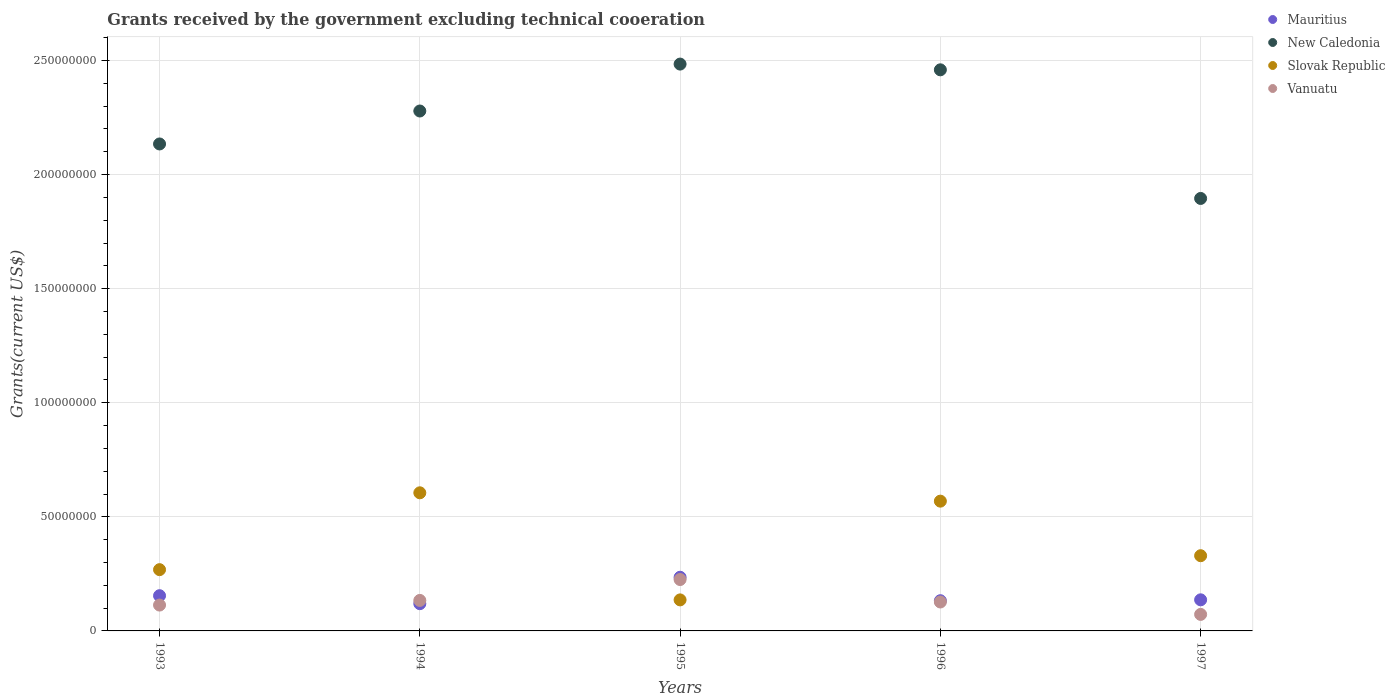Is the number of dotlines equal to the number of legend labels?
Make the answer very short. Yes. What is the total grants received by the government in Vanuatu in 1993?
Keep it short and to the point. 1.13e+07. Across all years, what is the maximum total grants received by the government in Slovak Republic?
Ensure brevity in your answer.  6.05e+07. Across all years, what is the minimum total grants received by the government in Slovak Republic?
Your answer should be very brief. 1.36e+07. In which year was the total grants received by the government in Mauritius maximum?
Your response must be concise. 1995. In which year was the total grants received by the government in New Caledonia minimum?
Your answer should be compact. 1997. What is the total total grants received by the government in Vanuatu in the graph?
Your response must be concise. 6.71e+07. What is the difference between the total grants received by the government in New Caledonia in 1993 and that in 1997?
Keep it short and to the point. 2.39e+07. What is the difference between the total grants received by the government in Mauritius in 1997 and the total grants received by the government in Slovak Republic in 1996?
Offer a terse response. -4.32e+07. What is the average total grants received by the government in Vanuatu per year?
Offer a terse response. 1.34e+07. In the year 1994, what is the difference between the total grants received by the government in Slovak Republic and total grants received by the government in Mauritius?
Keep it short and to the point. 4.86e+07. In how many years, is the total grants received by the government in Mauritius greater than 130000000 US$?
Keep it short and to the point. 0. What is the ratio of the total grants received by the government in Mauritius in 1994 to that in 1995?
Provide a short and direct response. 0.51. Is the difference between the total grants received by the government in Slovak Republic in 1994 and 1995 greater than the difference between the total grants received by the government in Mauritius in 1994 and 1995?
Your answer should be compact. Yes. What is the difference between the highest and the second highest total grants received by the government in New Caledonia?
Your answer should be compact. 2.51e+06. What is the difference between the highest and the lowest total grants received by the government in Vanuatu?
Offer a terse response. 1.53e+07. In how many years, is the total grants received by the government in New Caledonia greater than the average total grants received by the government in New Caledonia taken over all years?
Keep it short and to the point. 3. Does the total grants received by the government in Slovak Republic monotonically increase over the years?
Provide a short and direct response. No. Is the total grants received by the government in Vanuatu strictly greater than the total grants received by the government in Slovak Republic over the years?
Provide a succinct answer. No. Are the values on the major ticks of Y-axis written in scientific E-notation?
Make the answer very short. No. Does the graph contain any zero values?
Your answer should be compact. No. Does the graph contain grids?
Provide a short and direct response. Yes. How many legend labels are there?
Your answer should be compact. 4. What is the title of the graph?
Your answer should be compact. Grants received by the government excluding technical cooeration. What is the label or title of the Y-axis?
Provide a short and direct response. Grants(current US$). What is the Grants(current US$) of Mauritius in 1993?
Give a very brief answer. 1.54e+07. What is the Grants(current US$) of New Caledonia in 1993?
Provide a short and direct response. 2.13e+08. What is the Grants(current US$) in Slovak Republic in 1993?
Your answer should be compact. 2.68e+07. What is the Grants(current US$) in Vanuatu in 1993?
Your answer should be compact. 1.13e+07. What is the Grants(current US$) in Mauritius in 1994?
Provide a succinct answer. 1.19e+07. What is the Grants(current US$) in New Caledonia in 1994?
Make the answer very short. 2.28e+08. What is the Grants(current US$) in Slovak Republic in 1994?
Give a very brief answer. 6.05e+07. What is the Grants(current US$) of Vanuatu in 1994?
Make the answer very short. 1.34e+07. What is the Grants(current US$) in Mauritius in 1995?
Your answer should be very brief. 2.35e+07. What is the Grants(current US$) in New Caledonia in 1995?
Provide a succinct answer. 2.48e+08. What is the Grants(current US$) of Slovak Republic in 1995?
Offer a terse response. 1.36e+07. What is the Grants(current US$) of Vanuatu in 1995?
Offer a terse response. 2.25e+07. What is the Grants(current US$) in Mauritius in 1996?
Provide a succinct answer. 1.32e+07. What is the Grants(current US$) of New Caledonia in 1996?
Ensure brevity in your answer.  2.46e+08. What is the Grants(current US$) in Slovak Republic in 1996?
Your answer should be compact. 5.69e+07. What is the Grants(current US$) in Vanuatu in 1996?
Give a very brief answer. 1.27e+07. What is the Grants(current US$) of Mauritius in 1997?
Offer a terse response. 1.36e+07. What is the Grants(current US$) in New Caledonia in 1997?
Your answer should be very brief. 1.90e+08. What is the Grants(current US$) of Slovak Republic in 1997?
Your answer should be compact. 3.30e+07. What is the Grants(current US$) in Vanuatu in 1997?
Offer a very short reply. 7.24e+06. Across all years, what is the maximum Grants(current US$) of Mauritius?
Your answer should be very brief. 2.35e+07. Across all years, what is the maximum Grants(current US$) in New Caledonia?
Ensure brevity in your answer.  2.48e+08. Across all years, what is the maximum Grants(current US$) in Slovak Republic?
Offer a terse response. 6.05e+07. Across all years, what is the maximum Grants(current US$) in Vanuatu?
Provide a succinct answer. 2.25e+07. Across all years, what is the minimum Grants(current US$) in Mauritius?
Your answer should be very brief. 1.19e+07. Across all years, what is the minimum Grants(current US$) in New Caledonia?
Offer a very short reply. 1.90e+08. Across all years, what is the minimum Grants(current US$) of Slovak Republic?
Provide a short and direct response. 1.36e+07. Across all years, what is the minimum Grants(current US$) of Vanuatu?
Your answer should be very brief. 7.24e+06. What is the total Grants(current US$) in Mauritius in the graph?
Keep it short and to the point. 7.78e+07. What is the total Grants(current US$) in New Caledonia in the graph?
Your answer should be compact. 1.13e+09. What is the total Grants(current US$) of Slovak Republic in the graph?
Offer a terse response. 1.91e+08. What is the total Grants(current US$) of Vanuatu in the graph?
Give a very brief answer. 6.71e+07. What is the difference between the Grants(current US$) in Mauritius in 1993 and that in 1994?
Offer a very short reply. 3.50e+06. What is the difference between the Grants(current US$) in New Caledonia in 1993 and that in 1994?
Give a very brief answer. -1.44e+07. What is the difference between the Grants(current US$) of Slovak Republic in 1993 and that in 1994?
Offer a terse response. -3.37e+07. What is the difference between the Grants(current US$) in Vanuatu in 1993 and that in 1994?
Offer a terse response. -2.04e+06. What is the difference between the Grants(current US$) of Mauritius in 1993 and that in 1995?
Your response must be concise. -8.08e+06. What is the difference between the Grants(current US$) of New Caledonia in 1993 and that in 1995?
Offer a very short reply. -3.50e+07. What is the difference between the Grants(current US$) in Slovak Republic in 1993 and that in 1995?
Offer a terse response. 1.32e+07. What is the difference between the Grants(current US$) of Vanuatu in 1993 and that in 1995?
Make the answer very short. -1.12e+07. What is the difference between the Grants(current US$) of Mauritius in 1993 and that in 1996?
Offer a terse response. 2.20e+06. What is the difference between the Grants(current US$) of New Caledonia in 1993 and that in 1996?
Ensure brevity in your answer.  -3.25e+07. What is the difference between the Grants(current US$) of Slovak Republic in 1993 and that in 1996?
Provide a short and direct response. -3.00e+07. What is the difference between the Grants(current US$) in Vanuatu in 1993 and that in 1996?
Your response must be concise. -1.35e+06. What is the difference between the Grants(current US$) in Mauritius in 1993 and that in 1997?
Provide a short and direct response. 1.81e+06. What is the difference between the Grants(current US$) in New Caledonia in 1993 and that in 1997?
Give a very brief answer. 2.39e+07. What is the difference between the Grants(current US$) in Slovak Republic in 1993 and that in 1997?
Give a very brief answer. -6.11e+06. What is the difference between the Grants(current US$) of Vanuatu in 1993 and that in 1997?
Offer a very short reply. 4.09e+06. What is the difference between the Grants(current US$) of Mauritius in 1994 and that in 1995?
Keep it short and to the point. -1.16e+07. What is the difference between the Grants(current US$) of New Caledonia in 1994 and that in 1995?
Provide a short and direct response. -2.06e+07. What is the difference between the Grants(current US$) of Slovak Republic in 1994 and that in 1995?
Keep it short and to the point. 4.69e+07. What is the difference between the Grants(current US$) of Vanuatu in 1994 and that in 1995?
Make the answer very short. -9.15e+06. What is the difference between the Grants(current US$) in Mauritius in 1994 and that in 1996?
Your response must be concise. -1.30e+06. What is the difference between the Grants(current US$) in New Caledonia in 1994 and that in 1996?
Offer a very short reply. -1.80e+07. What is the difference between the Grants(current US$) in Slovak Republic in 1994 and that in 1996?
Offer a very short reply. 3.66e+06. What is the difference between the Grants(current US$) in Vanuatu in 1994 and that in 1996?
Your answer should be very brief. 6.90e+05. What is the difference between the Grants(current US$) in Mauritius in 1994 and that in 1997?
Your response must be concise. -1.69e+06. What is the difference between the Grants(current US$) of New Caledonia in 1994 and that in 1997?
Give a very brief answer. 3.83e+07. What is the difference between the Grants(current US$) in Slovak Republic in 1994 and that in 1997?
Offer a very short reply. 2.76e+07. What is the difference between the Grants(current US$) in Vanuatu in 1994 and that in 1997?
Provide a short and direct response. 6.13e+06. What is the difference between the Grants(current US$) of Mauritius in 1995 and that in 1996?
Keep it short and to the point. 1.03e+07. What is the difference between the Grants(current US$) of New Caledonia in 1995 and that in 1996?
Provide a short and direct response. 2.51e+06. What is the difference between the Grants(current US$) of Slovak Republic in 1995 and that in 1996?
Your response must be concise. -4.33e+07. What is the difference between the Grants(current US$) of Vanuatu in 1995 and that in 1996?
Keep it short and to the point. 9.84e+06. What is the difference between the Grants(current US$) in Mauritius in 1995 and that in 1997?
Keep it short and to the point. 9.89e+06. What is the difference between the Grants(current US$) in New Caledonia in 1995 and that in 1997?
Offer a terse response. 5.89e+07. What is the difference between the Grants(current US$) of Slovak Republic in 1995 and that in 1997?
Your response must be concise. -1.94e+07. What is the difference between the Grants(current US$) in Vanuatu in 1995 and that in 1997?
Your answer should be very brief. 1.53e+07. What is the difference between the Grants(current US$) of Mauritius in 1996 and that in 1997?
Give a very brief answer. -3.90e+05. What is the difference between the Grants(current US$) in New Caledonia in 1996 and that in 1997?
Offer a terse response. 5.64e+07. What is the difference between the Grants(current US$) in Slovak Republic in 1996 and that in 1997?
Provide a short and direct response. 2.39e+07. What is the difference between the Grants(current US$) in Vanuatu in 1996 and that in 1997?
Provide a short and direct response. 5.44e+06. What is the difference between the Grants(current US$) in Mauritius in 1993 and the Grants(current US$) in New Caledonia in 1994?
Your answer should be very brief. -2.12e+08. What is the difference between the Grants(current US$) of Mauritius in 1993 and the Grants(current US$) of Slovak Republic in 1994?
Provide a short and direct response. -4.51e+07. What is the difference between the Grants(current US$) in Mauritius in 1993 and the Grants(current US$) in Vanuatu in 1994?
Your response must be concise. 2.07e+06. What is the difference between the Grants(current US$) of New Caledonia in 1993 and the Grants(current US$) of Slovak Republic in 1994?
Ensure brevity in your answer.  1.53e+08. What is the difference between the Grants(current US$) in New Caledonia in 1993 and the Grants(current US$) in Vanuatu in 1994?
Offer a very short reply. 2.00e+08. What is the difference between the Grants(current US$) in Slovak Republic in 1993 and the Grants(current US$) in Vanuatu in 1994?
Your answer should be compact. 1.35e+07. What is the difference between the Grants(current US$) in Mauritius in 1993 and the Grants(current US$) in New Caledonia in 1995?
Keep it short and to the point. -2.33e+08. What is the difference between the Grants(current US$) in Mauritius in 1993 and the Grants(current US$) in Slovak Republic in 1995?
Offer a very short reply. 1.84e+06. What is the difference between the Grants(current US$) in Mauritius in 1993 and the Grants(current US$) in Vanuatu in 1995?
Your response must be concise. -7.08e+06. What is the difference between the Grants(current US$) in New Caledonia in 1993 and the Grants(current US$) in Slovak Republic in 1995?
Make the answer very short. 2.00e+08. What is the difference between the Grants(current US$) of New Caledonia in 1993 and the Grants(current US$) of Vanuatu in 1995?
Offer a very short reply. 1.91e+08. What is the difference between the Grants(current US$) of Slovak Republic in 1993 and the Grants(current US$) of Vanuatu in 1995?
Your answer should be very brief. 4.33e+06. What is the difference between the Grants(current US$) of Mauritius in 1993 and the Grants(current US$) of New Caledonia in 1996?
Your answer should be compact. -2.30e+08. What is the difference between the Grants(current US$) of Mauritius in 1993 and the Grants(current US$) of Slovak Republic in 1996?
Your answer should be compact. -4.14e+07. What is the difference between the Grants(current US$) of Mauritius in 1993 and the Grants(current US$) of Vanuatu in 1996?
Your response must be concise. 2.76e+06. What is the difference between the Grants(current US$) of New Caledonia in 1993 and the Grants(current US$) of Slovak Republic in 1996?
Keep it short and to the point. 1.57e+08. What is the difference between the Grants(current US$) of New Caledonia in 1993 and the Grants(current US$) of Vanuatu in 1996?
Your answer should be very brief. 2.01e+08. What is the difference between the Grants(current US$) of Slovak Republic in 1993 and the Grants(current US$) of Vanuatu in 1996?
Your answer should be very brief. 1.42e+07. What is the difference between the Grants(current US$) in Mauritius in 1993 and the Grants(current US$) in New Caledonia in 1997?
Ensure brevity in your answer.  -1.74e+08. What is the difference between the Grants(current US$) of Mauritius in 1993 and the Grants(current US$) of Slovak Republic in 1997?
Your answer should be very brief. -1.75e+07. What is the difference between the Grants(current US$) in Mauritius in 1993 and the Grants(current US$) in Vanuatu in 1997?
Your answer should be compact. 8.20e+06. What is the difference between the Grants(current US$) of New Caledonia in 1993 and the Grants(current US$) of Slovak Republic in 1997?
Make the answer very short. 1.80e+08. What is the difference between the Grants(current US$) in New Caledonia in 1993 and the Grants(current US$) in Vanuatu in 1997?
Offer a very short reply. 2.06e+08. What is the difference between the Grants(current US$) of Slovak Republic in 1993 and the Grants(current US$) of Vanuatu in 1997?
Your answer should be compact. 1.96e+07. What is the difference between the Grants(current US$) of Mauritius in 1994 and the Grants(current US$) of New Caledonia in 1995?
Provide a short and direct response. -2.36e+08. What is the difference between the Grants(current US$) of Mauritius in 1994 and the Grants(current US$) of Slovak Republic in 1995?
Make the answer very short. -1.66e+06. What is the difference between the Grants(current US$) in Mauritius in 1994 and the Grants(current US$) in Vanuatu in 1995?
Your answer should be very brief. -1.06e+07. What is the difference between the Grants(current US$) of New Caledonia in 1994 and the Grants(current US$) of Slovak Republic in 1995?
Make the answer very short. 2.14e+08. What is the difference between the Grants(current US$) of New Caledonia in 1994 and the Grants(current US$) of Vanuatu in 1995?
Your answer should be compact. 2.05e+08. What is the difference between the Grants(current US$) in Slovak Republic in 1994 and the Grants(current US$) in Vanuatu in 1995?
Your answer should be compact. 3.80e+07. What is the difference between the Grants(current US$) of Mauritius in 1994 and the Grants(current US$) of New Caledonia in 1996?
Give a very brief answer. -2.34e+08. What is the difference between the Grants(current US$) of Mauritius in 1994 and the Grants(current US$) of Slovak Republic in 1996?
Your response must be concise. -4.49e+07. What is the difference between the Grants(current US$) in Mauritius in 1994 and the Grants(current US$) in Vanuatu in 1996?
Your answer should be very brief. -7.40e+05. What is the difference between the Grants(current US$) of New Caledonia in 1994 and the Grants(current US$) of Slovak Republic in 1996?
Offer a very short reply. 1.71e+08. What is the difference between the Grants(current US$) of New Caledonia in 1994 and the Grants(current US$) of Vanuatu in 1996?
Provide a succinct answer. 2.15e+08. What is the difference between the Grants(current US$) of Slovak Republic in 1994 and the Grants(current US$) of Vanuatu in 1996?
Give a very brief answer. 4.78e+07. What is the difference between the Grants(current US$) in Mauritius in 1994 and the Grants(current US$) in New Caledonia in 1997?
Ensure brevity in your answer.  -1.78e+08. What is the difference between the Grants(current US$) of Mauritius in 1994 and the Grants(current US$) of Slovak Republic in 1997?
Provide a succinct answer. -2.10e+07. What is the difference between the Grants(current US$) in Mauritius in 1994 and the Grants(current US$) in Vanuatu in 1997?
Give a very brief answer. 4.70e+06. What is the difference between the Grants(current US$) of New Caledonia in 1994 and the Grants(current US$) of Slovak Republic in 1997?
Provide a short and direct response. 1.95e+08. What is the difference between the Grants(current US$) of New Caledonia in 1994 and the Grants(current US$) of Vanuatu in 1997?
Make the answer very short. 2.21e+08. What is the difference between the Grants(current US$) in Slovak Republic in 1994 and the Grants(current US$) in Vanuatu in 1997?
Provide a short and direct response. 5.33e+07. What is the difference between the Grants(current US$) of Mauritius in 1995 and the Grants(current US$) of New Caledonia in 1996?
Your response must be concise. -2.22e+08. What is the difference between the Grants(current US$) of Mauritius in 1995 and the Grants(current US$) of Slovak Republic in 1996?
Offer a terse response. -3.34e+07. What is the difference between the Grants(current US$) of Mauritius in 1995 and the Grants(current US$) of Vanuatu in 1996?
Your answer should be compact. 1.08e+07. What is the difference between the Grants(current US$) of New Caledonia in 1995 and the Grants(current US$) of Slovak Republic in 1996?
Provide a short and direct response. 1.92e+08. What is the difference between the Grants(current US$) of New Caledonia in 1995 and the Grants(current US$) of Vanuatu in 1996?
Keep it short and to the point. 2.36e+08. What is the difference between the Grants(current US$) of Slovak Republic in 1995 and the Grants(current US$) of Vanuatu in 1996?
Your answer should be very brief. 9.20e+05. What is the difference between the Grants(current US$) of Mauritius in 1995 and the Grants(current US$) of New Caledonia in 1997?
Your answer should be very brief. -1.66e+08. What is the difference between the Grants(current US$) of Mauritius in 1995 and the Grants(current US$) of Slovak Republic in 1997?
Make the answer very short. -9.44e+06. What is the difference between the Grants(current US$) in Mauritius in 1995 and the Grants(current US$) in Vanuatu in 1997?
Offer a terse response. 1.63e+07. What is the difference between the Grants(current US$) of New Caledonia in 1995 and the Grants(current US$) of Slovak Republic in 1997?
Offer a very short reply. 2.15e+08. What is the difference between the Grants(current US$) in New Caledonia in 1995 and the Grants(current US$) in Vanuatu in 1997?
Provide a short and direct response. 2.41e+08. What is the difference between the Grants(current US$) in Slovak Republic in 1995 and the Grants(current US$) in Vanuatu in 1997?
Your response must be concise. 6.36e+06. What is the difference between the Grants(current US$) in Mauritius in 1996 and the Grants(current US$) in New Caledonia in 1997?
Keep it short and to the point. -1.76e+08. What is the difference between the Grants(current US$) in Mauritius in 1996 and the Grants(current US$) in Slovak Republic in 1997?
Make the answer very short. -1.97e+07. What is the difference between the Grants(current US$) in Mauritius in 1996 and the Grants(current US$) in Vanuatu in 1997?
Offer a very short reply. 6.00e+06. What is the difference between the Grants(current US$) of New Caledonia in 1996 and the Grants(current US$) of Slovak Republic in 1997?
Your response must be concise. 2.13e+08. What is the difference between the Grants(current US$) in New Caledonia in 1996 and the Grants(current US$) in Vanuatu in 1997?
Offer a terse response. 2.39e+08. What is the difference between the Grants(current US$) of Slovak Republic in 1996 and the Grants(current US$) of Vanuatu in 1997?
Keep it short and to the point. 4.96e+07. What is the average Grants(current US$) in Mauritius per year?
Your response must be concise. 1.56e+07. What is the average Grants(current US$) in New Caledonia per year?
Provide a succinct answer. 2.25e+08. What is the average Grants(current US$) of Slovak Republic per year?
Give a very brief answer. 3.82e+07. What is the average Grants(current US$) of Vanuatu per year?
Provide a short and direct response. 1.34e+07. In the year 1993, what is the difference between the Grants(current US$) of Mauritius and Grants(current US$) of New Caledonia?
Your response must be concise. -1.98e+08. In the year 1993, what is the difference between the Grants(current US$) in Mauritius and Grants(current US$) in Slovak Republic?
Offer a terse response. -1.14e+07. In the year 1993, what is the difference between the Grants(current US$) in Mauritius and Grants(current US$) in Vanuatu?
Offer a very short reply. 4.11e+06. In the year 1993, what is the difference between the Grants(current US$) of New Caledonia and Grants(current US$) of Slovak Republic?
Make the answer very short. 1.87e+08. In the year 1993, what is the difference between the Grants(current US$) of New Caledonia and Grants(current US$) of Vanuatu?
Your answer should be very brief. 2.02e+08. In the year 1993, what is the difference between the Grants(current US$) of Slovak Republic and Grants(current US$) of Vanuatu?
Offer a terse response. 1.55e+07. In the year 1994, what is the difference between the Grants(current US$) in Mauritius and Grants(current US$) in New Caledonia?
Ensure brevity in your answer.  -2.16e+08. In the year 1994, what is the difference between the Grants(current US$) in Mauritius and Grants(current US$) in Slovak Republic?
Ensure brevity in your answer.  -4.86e+07. In the year 1994, what is the difference between the Grants(current US$) in Mauritius and Grants(current US$) in Vanuatu?
Your answer should be compact. -1.43e+06. In the year 1994, what is the difference between the Grants(current US$) of New Caledonia and Grants(current US$) of Slovak Republic?
Offer a very short reply. 1.67e+08. In the year 1994, what is the difference between the Grants(current US$) of New Caledonia and Grants(current US$) of Vanuatu?
Provide a succinct answer. 2.14e+08. In the year 1994, what is the difference between the Grants(current US$) in Slovak Republic and Grants(current US$) in Vanuatu?
Provide a succinct answer. 4.72e+07. In the year 1995, what is the difference between the Grants(current US$) of Mauritius and Grants(current US$) of New Caledonia?
Keep it short and to the point. -2.25e+08. In the year 1995, what is the difference between the Grants(current US$) of Mauritius and Grants(current US$) of Slovak Republic?
Provide a succinct answer. 9.92e+06. In the year 1995, what is the difference between the Grants(current US$) in New Caledonia and Grants(current US$) in Slovak Republic?
Your answer should be compact. 2.35e+08. In the year 1995, what is the difference between the Grants(current US$) in New Caledonia and Grants(current US$) in Vanuatu?
Make the answer very short. 2.26e+08. In the year 1995, what is the difference between the Grants(current US$) in Slovak Republic and Grants(current US$) in Vanuatu?
Your answer should be compact. -8.92e+06. In the year 1996, what is the difference between the Grants(current US$) in Mauritius and Grants(current US$) in New Caledonia?
Your answer should be compact. -2.33e+08. In the year 1996, what is the difference between the Grants(current US$) in Mauritius and Grants(current US$) in Slovak Republic?
Your response must be concise. -4.36e+07. In the year 1996, what is the difference between the Grants(current US$) in Mauritius and Grants(current US$) in Vanuatu?
Your answer should be compact. 5.60e+05. In the year 1996, what is the difference between the Grants(current US$) of New Caledonia and Grants(current US$) of Slovak Republic?
Provide a short and direct response. 1.89e+08. In the year 1996, what is the difference between the Grants(current US$) of New Caledonia and Grants(current US$) of Vanuatu?
Ensure brevity in your answer.  2.33e+08. In the year 1996, what is the difference between the Grants(current US$) of Slovak Republic and Grants(current US$) of Vanuatu?
Provide a succinct answer. 4.42e+07. In the year 1997, what is the difference between the Grants(current US$) in Mauritius and Grants(current US$) in New Caledonia?
Your answer should be very brief. -1.76e+08. In the year 1997, what is the difference between the Grants(current US$) in Mauritius and Grants(current US$) in Slovak Republic?
Provide a short and direct response. -1.93e+07. In the year 1997, what is the difference between the Grants(current US$) of Mauritius and Grants(current US$) of Vanuatu?
Provide a short and direct response. 6.39e+06. In the year 1997, what is the difference between the Grants(current US$) in New Caledonia and Grants(current US$) in Slovak Republic?
Keep it short and to the point. 1.57e+08. In the year 1997, what is the difference between the Grants(current US$) of New Caledonia and Grants(current US$) of Vanuatu?
Offer a terse response. 1.82e+08. In the year 1997, what is the difference between the Grants(current US$) of Slovak Republic and Grants(current US$) of Vanuatu?
Offer a terse response. 2.57e+07. What is the ratio of the Grants(current US$) in Mauritius in 1993 to that in 1994?
Provide a succinct answer. 1.29. What is the ratio of the Grants(current US$) in New Caledonia in 1993 to that in 1994?
Ensure brevity in your answer.  0.94. What is the ratio of the Grants(current US$) of Slovak Republic in 1993 to that in 1994?
Keep it short and to the point. 0.44. What is the ratio of the Grants(current US$) of Vanuatu in 1993 to that in 1994?
Provide a succinct answer. 0.85. What is the ratio of the Grants(current US$) in Mauritius in 1993 to that in 1995?
Give a very brief answer. 0.66. What is the ratio of the Grants(current US$) of New Caledonia in 1993 to that in 1995?
Your response must be concise. 0.86. What is the ratio of the Grants(current US$) of Slovak Republic in 1993 to that in 1995?
Your answer should be compact. 1.97. What is the ratio of the Grants(current US$) in Vanuatu in 1993 to that in 1995?
Keep it short and to the point. 0.5. What is the ratio of the Grants(current US$) in Mauritius in 1993 to that in 1996?
Provide a succinct answer. 1.17. What is the ratio of the Grants(current US$) in New Caledonia in 1993 to that in 1996?
Keep it short and to the point. 0.87. What is the ratio of the Grants(current US$) in Slovak Republic in 1993 to that in 1996?
Your answer should be very brief. 0.47. What is the ratio of the Grants(current US$) of Vanuatu in 1993 to that in 1996?
Offer a very short reply. 0.89. What is the ratio of the Grants(current US$) of Mauritius in 1993 to that in 1997?
Make the answer very short. 1.13. What is the ratio of the Grants(current US$) in New Caledonia in 1993 to that in 1997?
Offer a terse response. 1.13. What is the ratio of the Grants(current US$) in Slovak Republic in 1993 to that in 1997?
Your answer should be very brief. 0.81. What is the ratio of the Grants(current US$) of Vanuatu in 1993 to that in 1997?
Your response must be concise. 1.56. What is the ratio of the Grants(current US$) in Mauritius in 1994 to that in 1995?
Your answer should be compact. 0.51. What is the ratio of the Grants(current US$) of New Caledonia in 1994 to that in 1995?
Your answer should be very brief. 0.92. What is the ratio of the Grants(current US$) in Slovak Republic in 1994 to that in 1995?
Offer a very short reply. 4.45. What is the ratio of the Grants(current US$) of Vanuatu in 1994 to that in 1995?
Offer a very short reply. 0.59. What is the ratio of the Grants(current US$) of Mauritius in 1994 to that in 1996?
Make the answer very short. 0.9. What is the ratio of the Grants(current US$) of New Caledonia in 1994 to that in 1996?
Keep it short and to the point. 0.93. What is the ratio of the Grants(current US$) in Slovak Republic in 1994 to that in 1996?
Your answer should be compact. 1.06. What is the ratio of the Grants(current US$) of Vanuatu in 1994 to that in 1996?
Your response must be concise. 1.05. What is the ratio of the Grants(current US$) of Mauritius in 1994 to that in 1997?
Offer a terse response. 0.88. What is the ratio of the Grants(current US$) of New Caledonia in 1994 to that in 1997?
Make the answer very short. 1.2. What is the ratio of the Grants(current US$) of Slovak Republic in 1994 to that in 1997?
Offer a terse response. 1.84. What is the ratio of the Grants(current US$) in Vanuatu in 1994 to that in 1997?
Offer a terse response. 1.85. What is the ratio of the Grants(current US$) in Mauritius in 1995 to that in 1996?
Your response must be concise. 1.78. What is the ratio of the Grants(current US$) of New Caledonia in 1995 to that in 1996?
Offer a very short reply. 1.01. What is the ratio of the Grants(current US$) of Slovak Republic in 1995 to that in 1996?
Your answer should be compact. 0.24. What is the ratio of the Grants(current US$) of Vanuatu in 1995 to that in 1996?
Your answer should be compact. 1.78. What is the ratio of the Grants(current US$) of Mauritius in 1995 to that in 1997?
Your answer should be compact. 1.73. What is the ratio of the Grants(current US$) of New Caledonia in 1995 to that in 1997?
Provide a short and direct response. 1.31. What is the ratio of the Grants(current US$) of Slovak Republic in 1995 to that in 1997?
Provide a succinct answer. 0.41. What is the ratio of the Grants(current US$) in Vanuatu in 1995 to that in 1997?
Offer a terse response. 3.11. What is the ratio of the Grants(current US$) of Mauritius in 1996 to that in 1997?
Offer a very short reply. 0.97. What is the ratio of the Grants(current US$) of New Caledonia in 1996 to that in 1997?
Give a very brief answer. 1.3. What is the ratio of the Grants(current US$) of Slovak Republic in 1996 to that in 1997?
Offer a terse response. 1.73. What is the ratio of the Grants(current US$) in Vanuatu in 1996 to that in 1997?
Give a very brief answer. 1.75. What is the difference between the highest and the second highest Grants(current US$) in Mauritius?
Keep it short and to the point. 8.08e+06. What is the difference between the highest and the second highest Grants(current US$) of New Caledonia?
Provide a succinct answer. 2.51e+06. What is the difference between the highest and the second highest Grants(current US$) in Slovak Republic?
Give a very brief answer. 3.66e+06. What is the difference between the highest and the second highest Grants(current US$) in Vanuatu?
Provide a short and direct response. 9.15e+06. What is the difference between the highest and the lowest Grants(current US$) of Mauritius?
Offer a very short reply. 1.16e+07. What is the difference between the highest and the lowest Grants(current US$) of New Caledonia?
Your answer should be compact. 5.89e+07. What is the difference between the highest and the lowest Grants(current US$) in Slovak Republic?
Keep it short and to the point. 4.69e+07. What is the difference between the highest and the lowest Grants(current US$) in Vanuatu?
Give a very brief answer. 1.53e+07. 